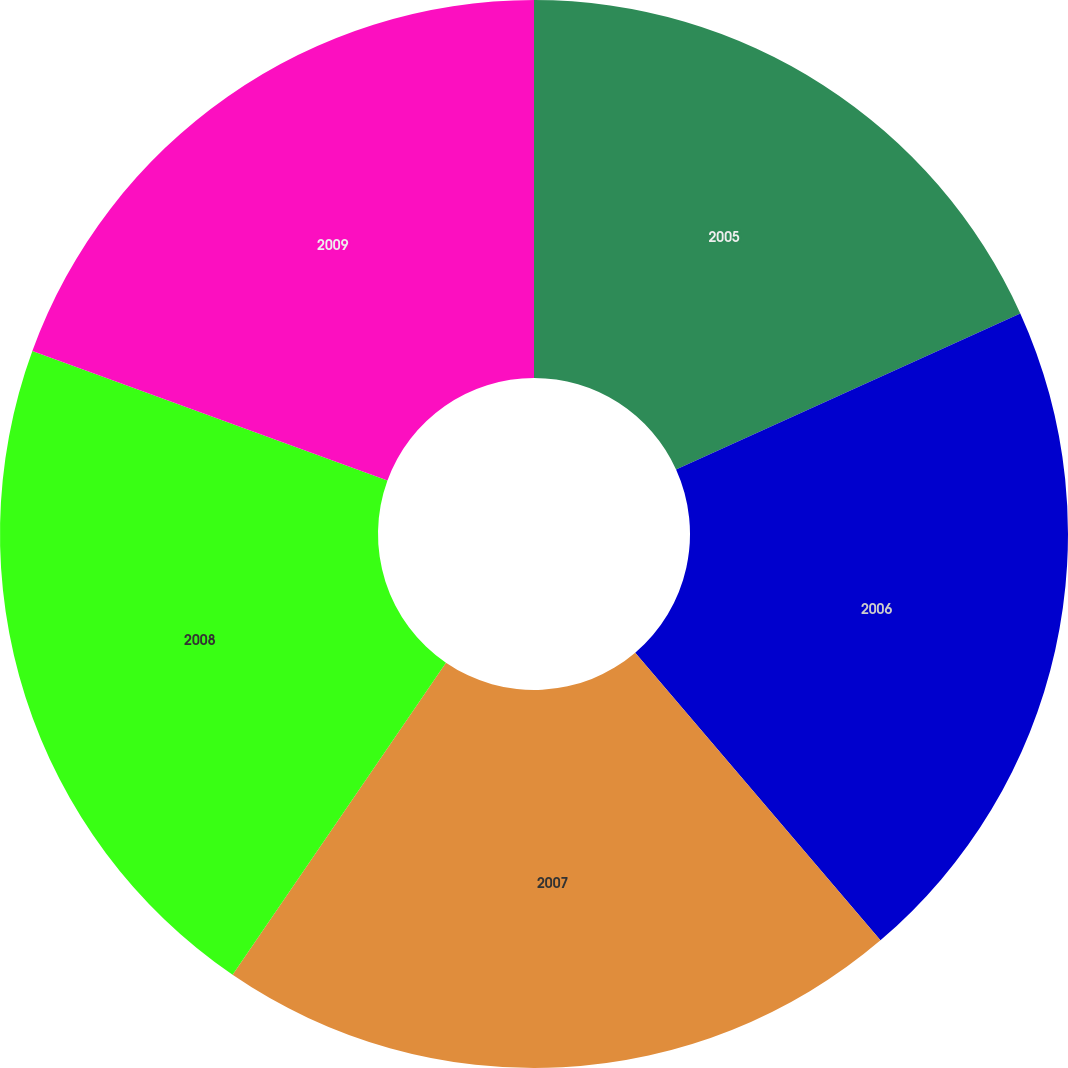Convert chart. <chart><loc_0><loc_0><loc_500><loc_500><pie_chart><fcel>2005<fcel>2006<fcel>2007<fcel>2008<fcel>2009<nl><fcel>18.22%<fcel>20.54%<fcel>20.78%<fcel>21.02%<fcel>19.43%<nl></chart> 